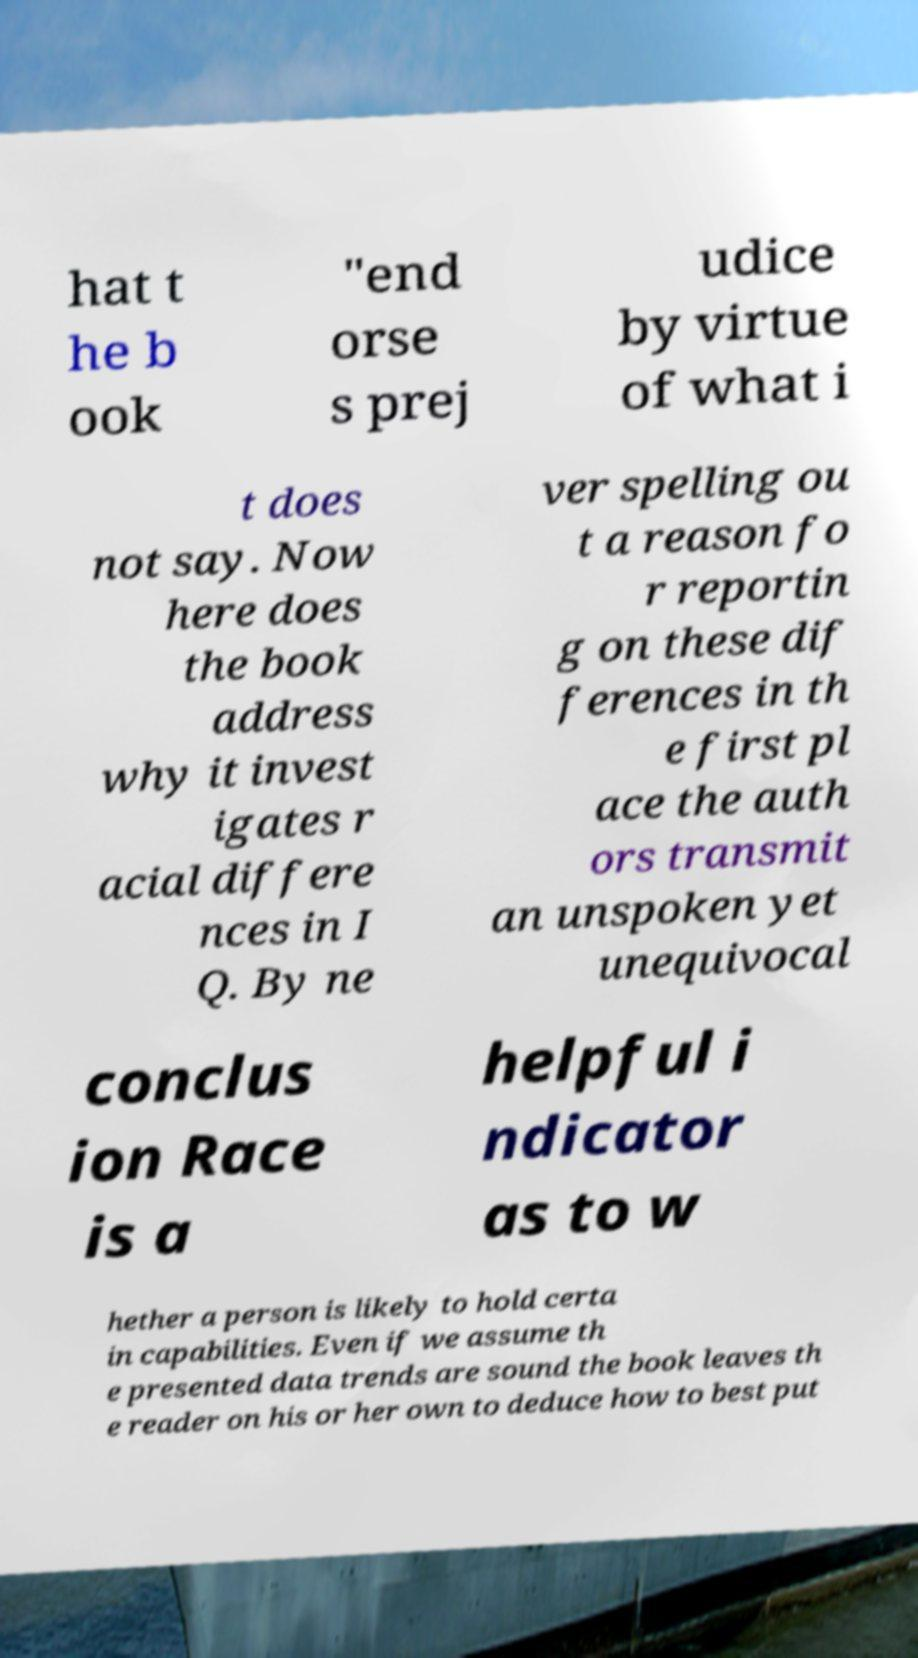Please read and relay the text visible in this image. What does it say? hat t he b ook "end orse s prej udice by virtue of what i t does not say. Now here does the book address why it invest igates r acial differe nces in I Q. By ne ver spelling ou t a reason fo r reportin g on these dif ferences in th e first pl ace the auth ors transmit an unspoken yet unequivocal conclus ion Race is a helpful i ndicator as to w hether a person is likely to hold certa in capabilities. Even if we assume th e presented data trends are sound the book leaves th e reader on his or her own to deduce how to best put 